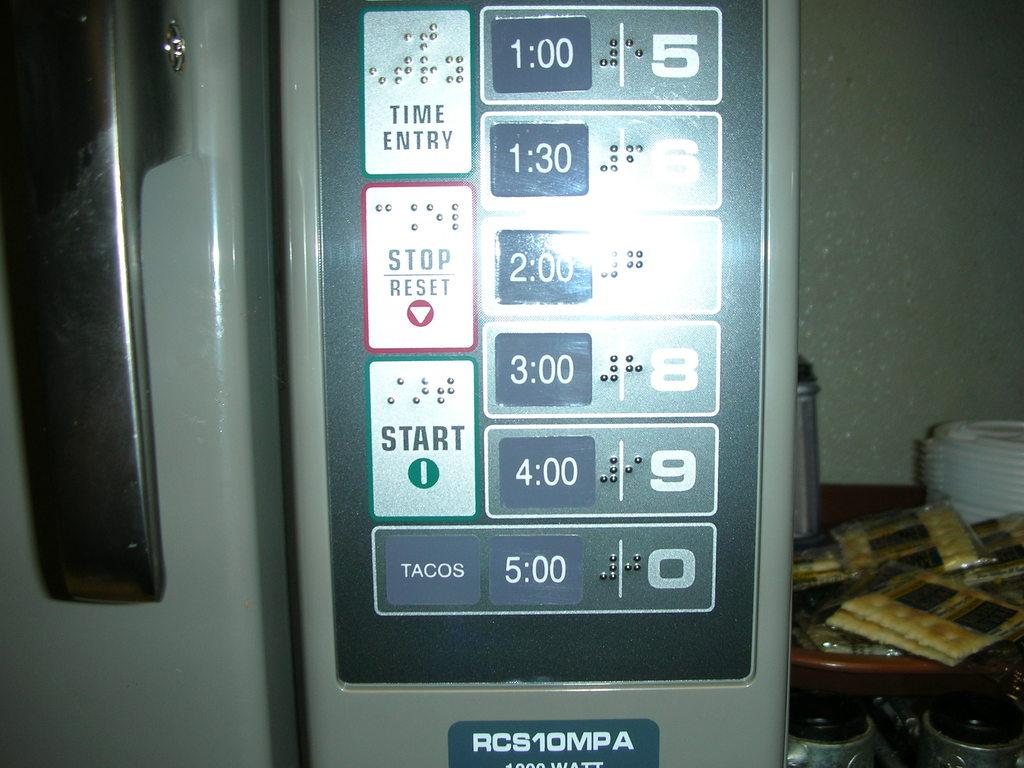<image>
Share a concise interpretation of the image provided. A control pad has buttons for time entry, stop/reset and start. 